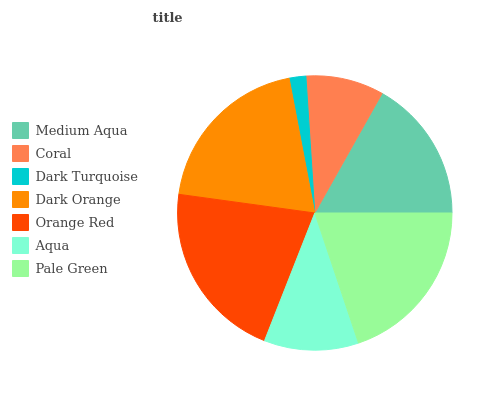Is Dark Turquoise the minimum?
Answer yes or no. Yes. Is Orange Red the maximum?
Answer yes or no. Yes. Is Coral the minimum?
Answer yes or no. No. Is Coral the maximum?
Answer yes or no. No. Is Medium Aqua greater than Coral?
Answer yes or no. Yes. Is Coral less than Medium Aqua?
Answer yes or no. Yes. Is Coral greater than Medium Aqua?
Answer yes or no. No. Is Medium Aqua less than Coral?
Answer yes or no. No. Is Medium Aqua the high median?
Answer yes or no. Yes. Is Medium Aqua the low median?
Answer yes or no. Yes. Is Orange Red the high median?
Answer yes or no. No. Is Aqua the low median?
Answer yes or no. No. 